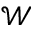Convert formula to latex. <formula><loc_0><loc_0><loc_500><loc_500>\mathcal { W }</formula> 